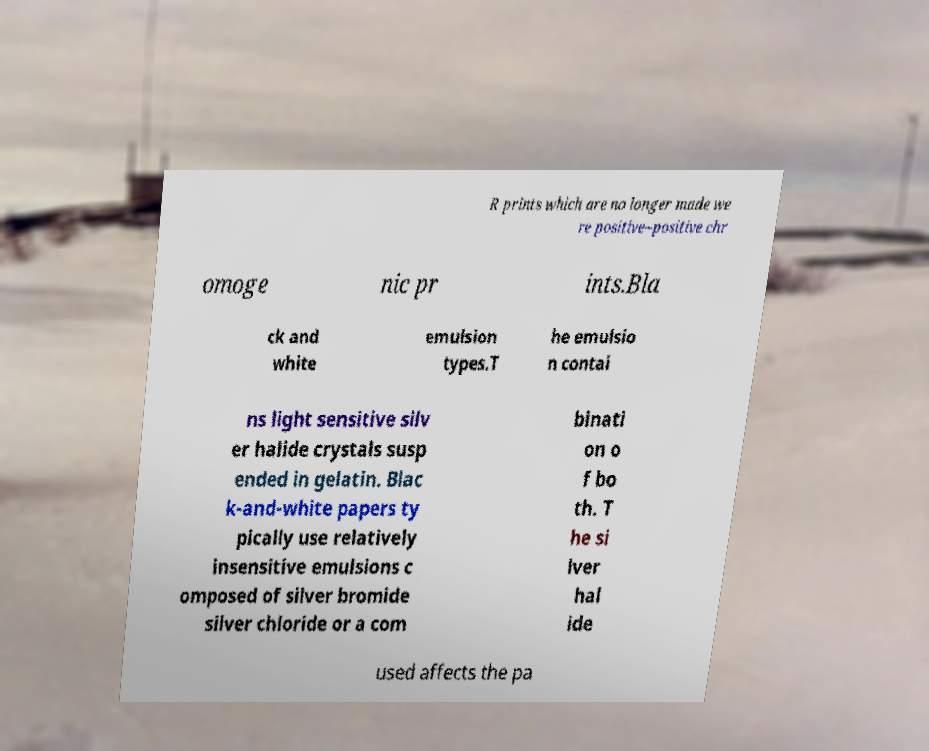Can you read and provide the text displayed in the image?This photo seems to have some interesting text. Can you extract and type it out for me? R prints which are no longer made we re positive–positive chr omoge nic pr ints.Bla ck and white emulsion types.T he emulsio n contai ns light sensitive silv er halide crystals susp ended in gelatin. Blac k-and-white papers ty pically use relatively insensitive emulsions c omposed of silver bromide silver chloride or a com binati on o f bo th. T he si lver hal ide used affects the pa 